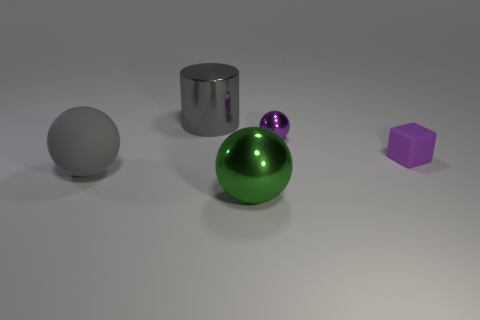There is a large metallic object in front of the matte block; what is its color?
Keep it short and to the point. Green. There is a metal object that is left of the large green thing; how many rubber things are to the right of it?
Offer a very short reply. 1. There is a cylinder; is it the same size as the metal object that is in front of the purple shiny object?
Your answer should be very brief. Yes. Is there another green ball that has the same size as the rubber ball?
Your response must be concise. Yes. How many objects are either small things or large gray metal cylinders?
Keep it short and to the point. 3. Is the size of the ball that is behind the tiny matte cube the same as the matte object that is on the right side of the big gray matte ball?
Provide a short and direct response. Yes. Are there any other things of the same shape as the purple metallic object?
Provide a short and direct response. Yes. Are there fewer gray metal things that are left of the gray shiny cylinder than large purple metallic cubes?
Give a very brief answer. No. Is the green object the same shape as the large gray rubber thing?
Keep it short and to the point. Yes. What size is the rubber object right of the tiny metallic ball?
Offer a very short reply. Small. 